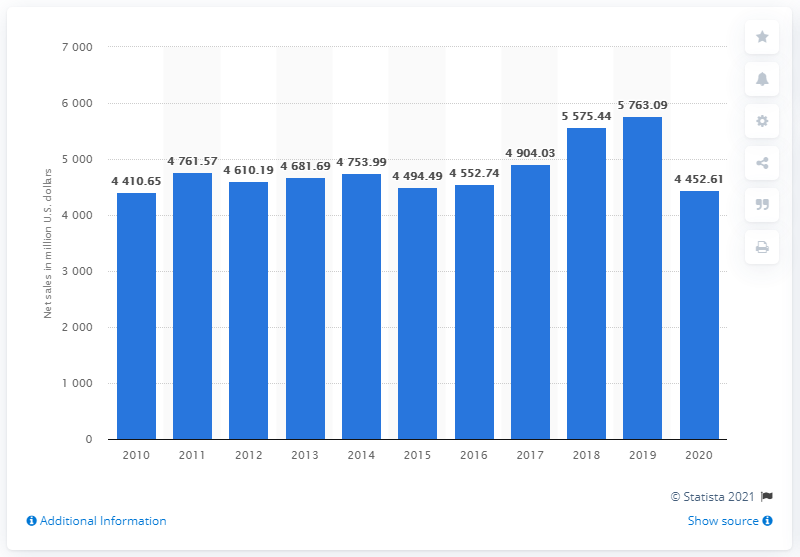Highlight a few significant elements in this photo. In 2020, the net sales of Levi Strauss were 4452.61. 